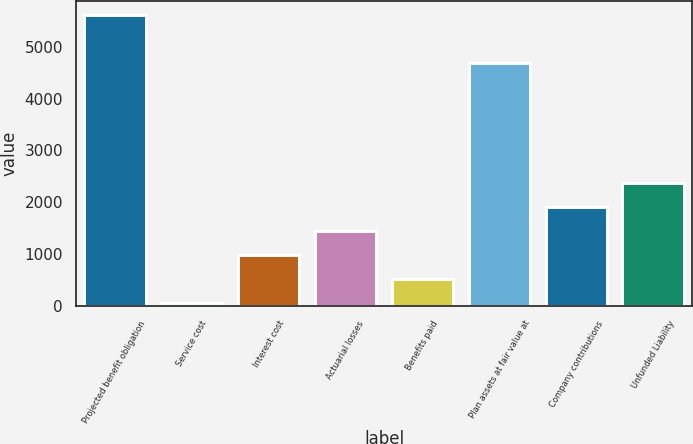Convert chart. <chart><loc_0><loc_0><loc_500><loc_500><bar_chart><fcel>Projected benefit obligation<fcel>Service cost<fcel>Interest cost<fcel>Actuarial losses<fcel>Benefits paid<fcel>Plan assets at fair value at<fcel>Company contributions<fcel>Unfunded Liability<nl><fcel>5604.8<fcel>64<fcel>984.4<fcel>1444.6<fcel>524.2<fcel>4684.4<fcel>1904.8<fcel>2365<nl></chart> 